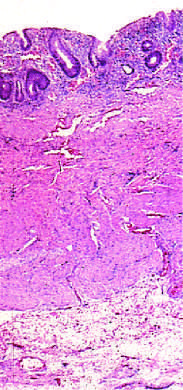s disease limited to the mucosa?
Answer the question using a single word or phrase. Yes 